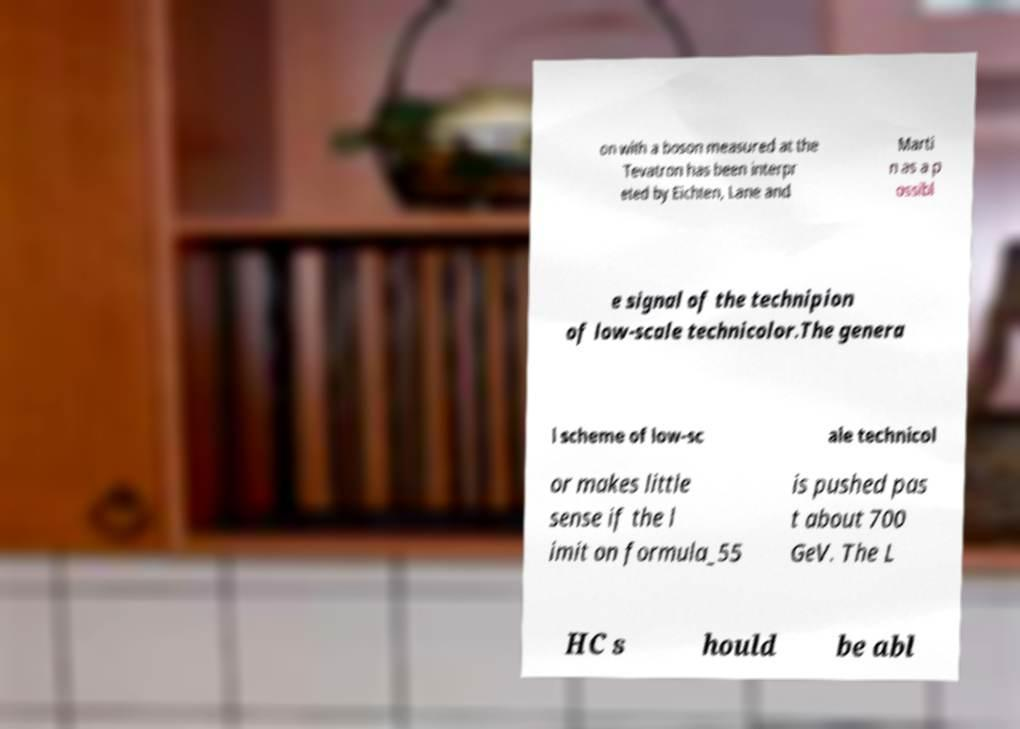Could you extract and type out the text from this image? on with a boson measured at the Tevatron has been interpr eted by Eichten, Lane and Marti n as a p ossibl e signal of the technipion of low-scale technicolor.The genera l scheme of low-sc ale technicol or makes little sense if the l imit on formula_55 is pushed pas t about 700 GeV. The L HC s hould be abl 